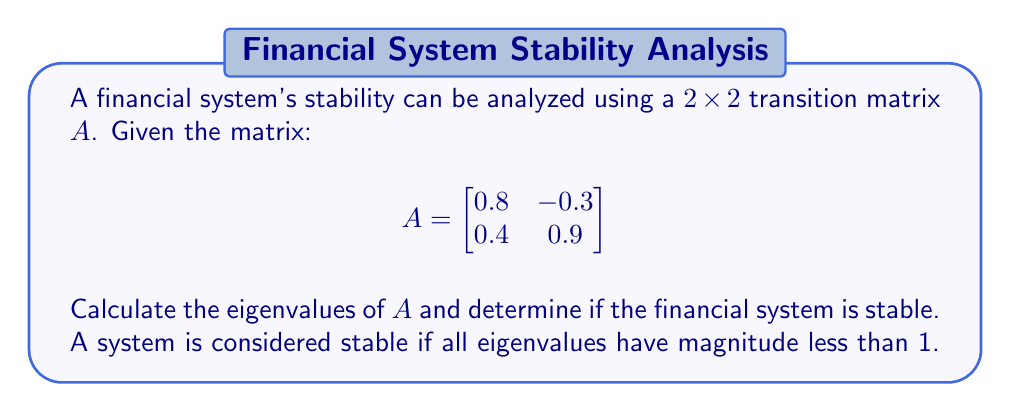Can you answer this question? 1) To find the eigenvalues, we need to solve the characteristic equation:
   $\det(A - \lambda I) = 0$

2) Expanding this:
   $$\begin{vmatrix}
   0.8 - \lambda & -0.3 \\
   0.4 & 0.9 - \lambda
   \end{vmatrix} = 0$$

3) $(0.8 - \lambda)(0.9 - \lambda) - (-0.3)(0.4) = 0$

4) $\lambda^2 - 1.7\lambda + 0.6 = 0$

5) Using the quadratic formula $\lambda = \frac{-b \pm \sqrt{b^2 - 4ac}}{2a}$:

   $\lambda = \frac{1.7 \pm \sqrt{1.7^2 - 4(1)(0.6)}}{2(1)}$

6) $\lambda = \frac{1.7 \pm \sqrt{2.89 - 2.4}}{2} = \frac{1.7 \pm \sqrt{0.49}}{2} = \frac{1.7 \pm 0.7}{2}$

7) Therefore, $\lambda_1 = \frac{1.7 + 0.7}{2} = 1.2$ and $\lambda_2 = \frac{1.7 - 0.7}{2} = 0.5$

8) Check magnitudes: $|\lambda_1| = 1.2 > 1$ and $|\lambda_2| = 0.5 < 1$

9) Since $|\lambda_1| > 1$, the system is unstable.
Answer: Unstable; eigenvalues are 1.2 and 0.5 